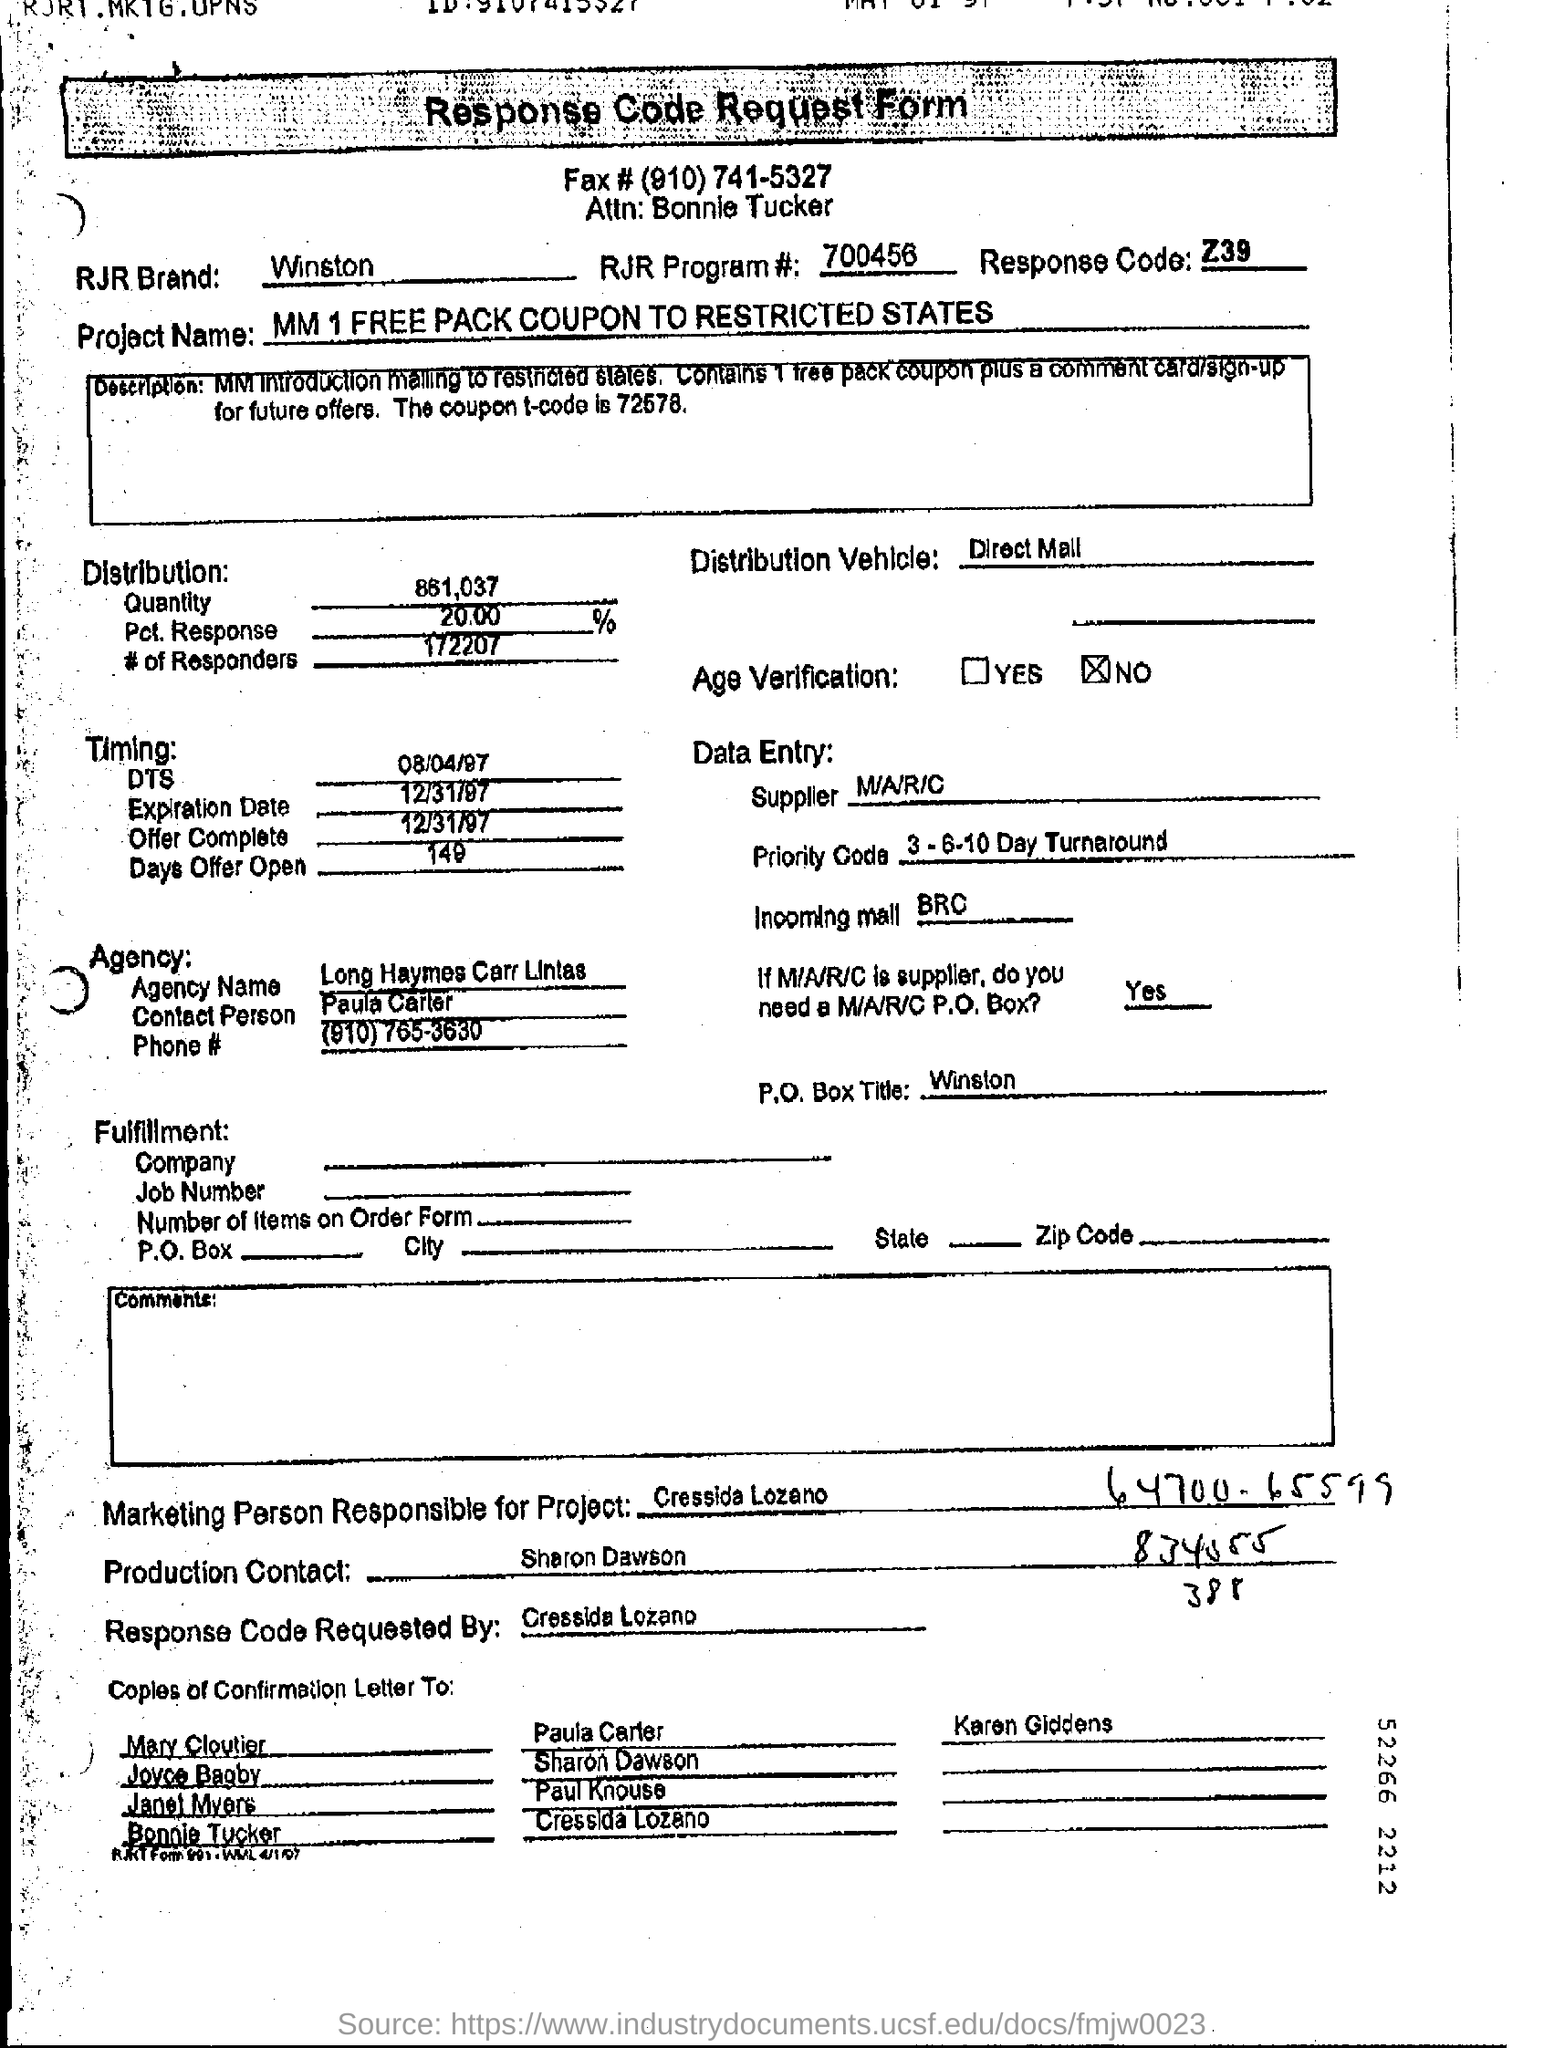Identify some key points in this picture. What is the Response Code?" is a question that requires a response in the form of a code, specifically the Z39 code. The RJR Program number is #700456 with more digits. The RJR Brand, specifically related to Winston cigarettes, is a well-known and established brand in the tobacco industry. 